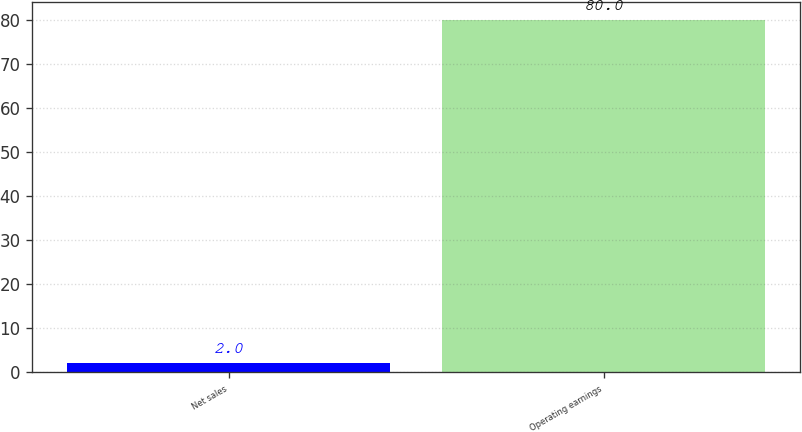<chart> <loc_0><loc_0><loc_500><loc_500><bar_chart><fcel>Net sales<fcel>Operating earnings<nl><fcel>2<fcel>80<nl></chart> 